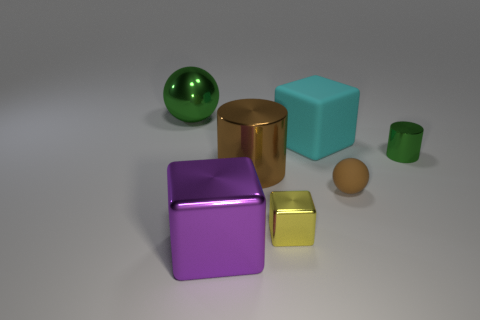Subtract all yellow cubes. How many cubes are left? 2 Subtract all purple cubes. How many cubes are left? 2 Add 1 big matte things. How many objects exist? 8 Subtract all spheres. How many objects are left? 5 Add 5 big brown cylinders. How many big brown cylinders exist? 6 Subtract 0 gray cylinders. How many objects are left? 7 Subtract 1 cylinders. How many cylinders are left? 1 Subtract all gray blocks. Subtract all cyan spheres. How many blocks are left? 3 Subtract all green spheres. How many brown cylinders are left? 1 Subtract all tiny green things. Subtract all small yellow metal blocks. How many objects are left? 5 